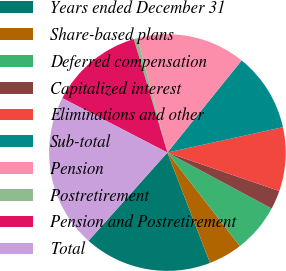Convert chart. <chart><loc_0><loc_0><loc_500><loc_500><pie_chart><fcel>Years ended December 31<fcel>Share-based plans<fcel>Deferred compensation<fcel>Capitalized interest<fcel>Eliminations and other<fcel>Sub-total<fcel>Pension<fcel>Postretirement<fcel>Pension and Postretirement<fcel>Total<nl><fcel>17.48%<fcel>4.62%<fcel>6.67%<fcel>2.57%<fcel>8.71%<fcel>10.76%<fcel>14.86%<fcel>0.52%<fcel>12.81%<fcel>21.0%<nl></chart> 